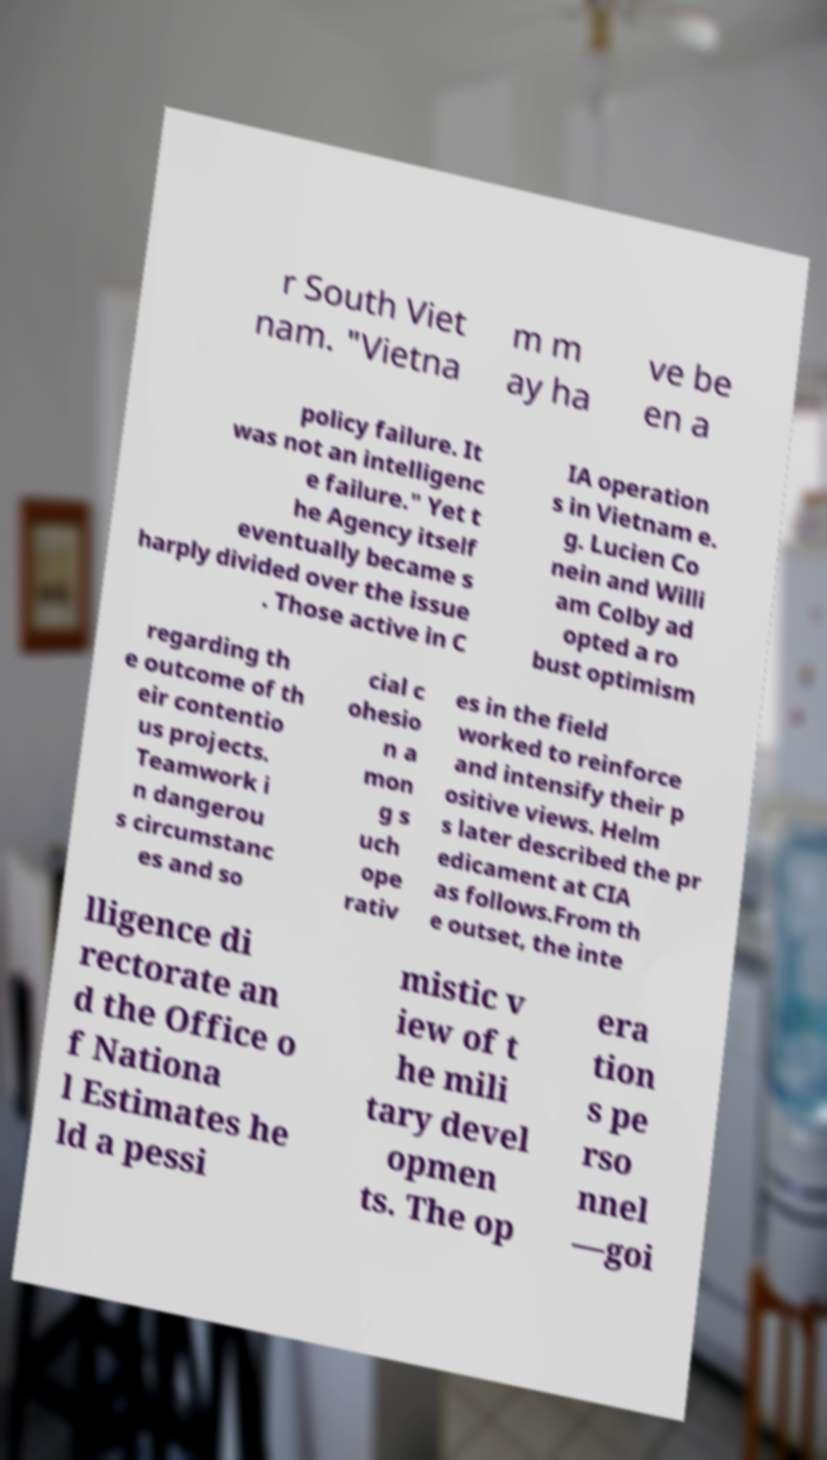What messages or text are displayed in this image? I need them in a readable, typed format. r South Viet nam. "Vietna m m ay ha ve be en a policy failure. It was not an intelligenc e failure." Yet t he Agency itself eventually became s harply divided over the issue . Those active in C IA operation s in Vietnam e. g. Lucien Co nein and Willi am Colby ad opted a ro bust optimism regarding th e outcome of th eir contentio us projects. Teamwork i n dangerou s circumstanc es and so cial c ohesio n a mon g s uch ope rativ es in the field worked to reinforce and intensify their p ositive views. Helm s later described the pr edicament at CIA as follows.From th e outset, the inte lligence di rectorate an d the Office o f Nationa l Estimates he ld a pessi mistic v iew of t he mili tary devel opmen ts. The op era tion s pe rso nnel —goi 